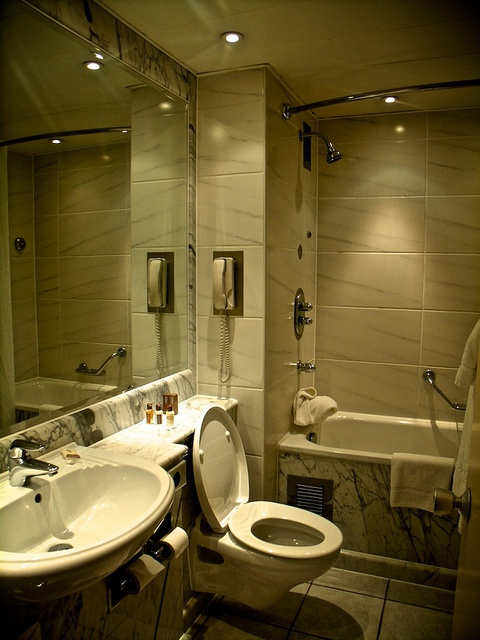Describe the objects in this image and their specific colors. I can see toilet in black, olive, tan, and khaki tones, sink in black, khaki, tan, and lightyellow tones, bottle in black, beige, khaki, tan, and maroon tones, bottle in black, khaki, olive, maroon, and lightyellow tones, and bottle in black, olive, orange, tan, and maroon tones in this image. 